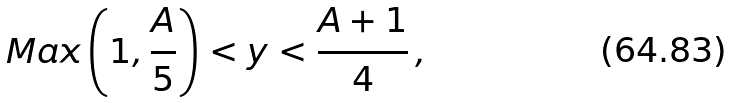<formula> <loc_0><loc_0><loc_500><loc_500>M a x \left ( 1 , \frac { A } { 5 } \right ) < y < \frac { A + 1 } { 4 } \, ,</formula> 